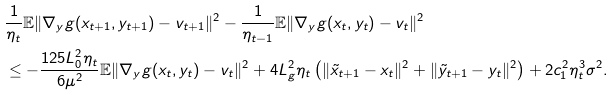Convert formula to latex. <formula><loc_0><loc_0><loc_500><loc_500>& \frac { 1 } { \eta _ { t } } \mathbb { E } \| \nabla _ { y } g ( x _ { t + 1 } , y _ { t + 1 } ) - v _ { t + 1 } \| ^ { 2 } - \frac { 1 } { \eta _ { t - 1 } } \mathbb { E } \| \nabla _ { y } g ( x _ { t } , y _ { t } ) - v _ { t } \| ^ { 2 } \\ & \leq - \frac { 1 2 5 L ^ { 2 } _ { 0 } \eta _ { t } } { 6 \mu ^ { 2 } } \mathbb { E } \| \nabla _ { y } g ( x _ { t } , y _ { t } ) - v _ { t } \| ^ { 2 } + 4 L ^ { 2 } _ { g } \eta _ { t } \left ( \| \tilde { x } _ { t + 1 } - x _ { t } \| ^ { 2 } + \| \tilde { y } _ { t + 1 } - y _ { t } \| ^ { 2 } \right ) + 2 c _ { 1 } ^ { 2 } \eta ^ { 3 } _ { t } \sigma ^ { 2 } .</formula> 